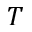Convert formula to latex. <formula><loc_0><loc_0><loc_500><loc_500>T</formula> 